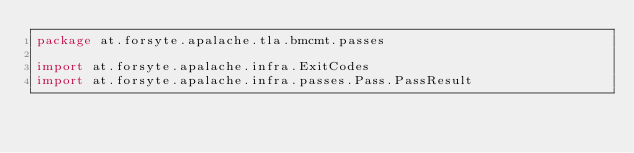Convert code to text. <code><loc_0><loc_0><loc_500><loc_500><_Scala_>package at.forsyte.apalache.tla.bmcmt.passes

import at.forsyte.apalache.infra.ExitCodes
import at.forsyte.apalache.infra.passes.Pass.PassResult</code> 